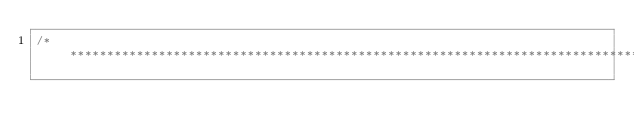Convert code to text. <code><loc_0><loc_0><loc_500><loc_500><_C++_>/******************************************************************************</code> 